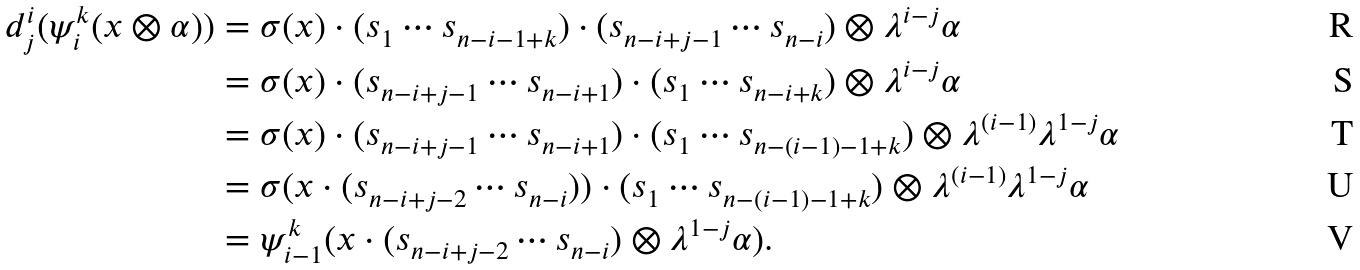<formula> <loc_0><loc_0><loc_500><loc_500>d ^ { i } _ { j } ( \psi ^ { k } _ { i } ( x \otimes \alpha ) ) & = \sigma ( x ) \cdot ( s _ { 1 } \cdots s _ { n - i - 1 + k } ) \cdot ( s _ { n - i + j - 1 } \cdots s _ { n - i } ) \otimes \lambda ^ { i - j } \alpha \\ & = \sigma ( x ) \cdot ( s _ { n - i + j - 1 } \cdots s _ { n - i + 1 } ) \cdot ( s _ { 1 } \cdots s _ { n - i + k } ) \otimes \lambda ^ { i - j } \alpha \\ & = \sigma ( x ) \cdot ( s _ { n - i + j - 1 } \cdots s _ { n - i + 1 } ) \cdot ( s _ { 1 } \cdots s _ { n - ( i - 1 ) - 1 + k } ) \otimes \lambda ^ { ( i - 1 ) } \lambda ^ { 1 - j } \alpha \\ & = \sigma ( x \cdot ( s _ { n - i + j - 2 } \cdots s _ { n - i } ) ) \cdot ( s _ { 1 } \cdots s _ { n - ( i - 1 ) - 1 + k } ) \otimes \lambda ^ { ( i - 1 ) } \lambda ^ { 1 - j } \alpha \\ & = \psi ^ { k } _ { i - 1 } ( x \cdot ( s _ { n - i + j - 2 } \cdots s _ { n - i } ) \otimes \lambda ^ { 1 - j } \alpha ) .</formula> 